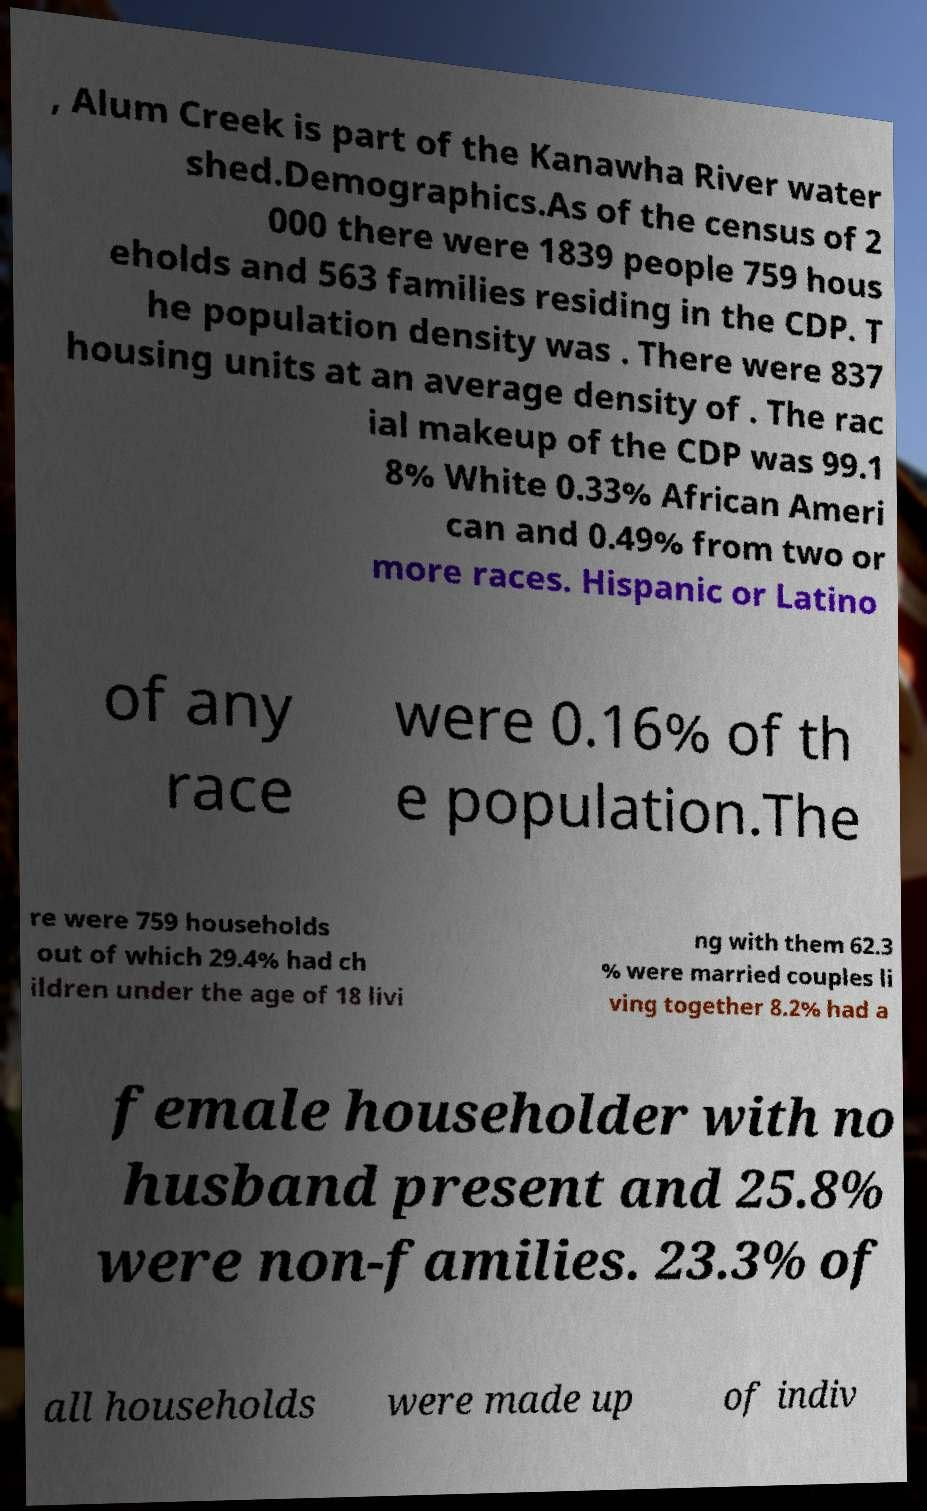What messages or text are displayed in this image? I need them in a readable, typed format. , Alum Creek is part of the Kanawha River water shed.Demographics.As of the census of 2 000 there were 1839 people 759 hous eholds and 563 families residing in the CDP. T he population density was . There were 837 housing units at an average density of . The rac ial makeup of the CDP was 99.1 8% White 0.33% African Ameri can and 0.49% from two or more races. Hispanic or Latino of any race were 0.16% of th e population.The re were 759 households out of which 29.4% had ch ildren under the age of 18 livi ng with them 62.3 % were married couples li ving together 8.2% had a female householder with no husband present and 25.8% were non-families. 23.3% of all households were made up of indiv 